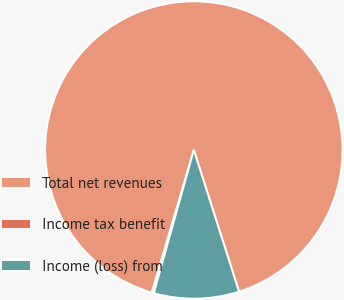Convert chart. <chart><loc_0><loc_0><loc_500><loc_500><pie_chart><fcel>Total net revenues<fcel>Income tax benefit<fcel>Income (loss) from<nl><fcel>90.53%<fcel>0.22%<fcel>9.25%<nl></chart> 